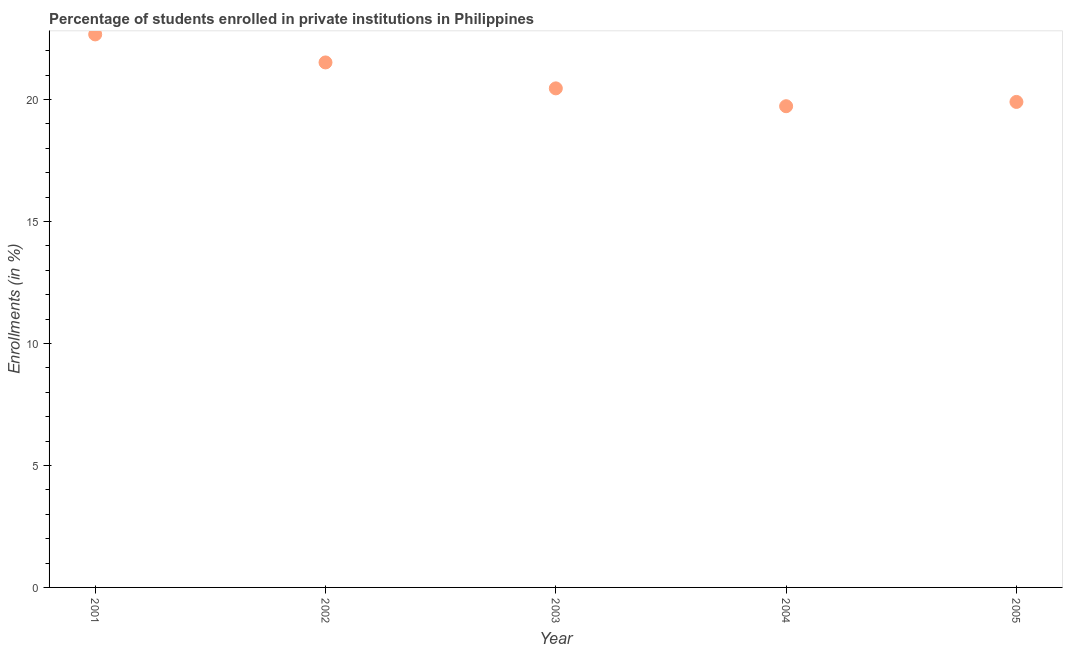What is the enrollments in private institutions in 2002?
Provide a short and direct response. 21.52. Across all years, what is the maximum enrollments in private institutions?
Your response must be concise. 22.67. Across all years, what is the minimum enrollments in private institutions?
Make the answer very short. 19.72. In which year was the enrollments in private institutions minimum?
Your answer should be very brief. 2004. What is the sum of the enrollments in private institutions?
Offer a very short reply. 104.26. What is the difference between the enrollments in private institutions in 2004 and 2005?
Give a very brief answer. -0.18. What is the average enrollments in private institutions per year?
Your answer should be very brief. 20.85. What is the median enrollments in private institutions?
Provide a succinct answer. 20.45. In how many years, is the enrollments in private institutions greater than 7 %?
Provide a short and direct response. 5. Do a majority of the years between 2003 and 2002 (inclusive) have enrollments in private institutions greater than 11 %?
Your response must be concise. No. What is the ratio of the enrollments in private institutions in 2002 to that in 2004?
Provide a short and direct response. 1.09. Is the difference between the enrollments in private institutions in 2002 and 2003 greater than the difference between any two years?
Keep it short and to the point. No. What is the difference between the highest and the second highest enrollments in private institutions?
Give a very brief answer. 1.15. What is the difference between the highest and the lowest enrollments in private institutions?
Your answer should be very brief. 2.94. In how many years, is the enrollments in private institutions greater than the average enrollments in private institutions taken over all years?
Give a very brief answer. 2. Does the enrollments in private institutions monotonically increase over the years?
Make the answer very short. No. How many dotlines are there?
Keep it short and to the point. 1. How many years are there in the graph?
Your answer should be very brief. 5. What is the difference between two consecutive major ticks on the Y-axis?
Your response must be concise. 5. Are the values on the major ticks of Y-axis written in scientific E-notation?
Offer a terse response. No. What is the title of the graph?
Give a very brief answer. Percentage of students enrolled in private institutions in Philippines. What is the label or title of the X-axis?
Offer a very short reply. Year. What is the label or title of the Y-axis?
Offer a terse response. Enrollments (in %). What is the Enrollments (in %) in 2001?
Make the answer very short. 22.67. What is the Enrollments (in %) in 2002?
Your answer should be very brief. 21.52. What is the Enrollments (in %) in 2003?
Your answer should be very brief. 20.45. What is the Enrollments (in %) in 2004?
Give a very brief answer. 19.72. What is the Enrollments (in %) in 2005?
Your answer should be compact. 19.9. What is the difference between the Enrollments (in %) in 2001 and 2002?
Provide a succinct answer. 1.15. What is the difference between the Enrollments (in %) in 2001 and 2003?
Your answer should be very brief. 2.21. What is the difference between the Enrollments (in %) in 2001 and 2004?
Offer a terse response. 2.94. What is the difference between the Enrollments (in %) in 2001 and 2005?
Offer a very short reply. 2.77. What is the difference between the Enrollments (in %) in 2002 and 2003?
Keep it short and to the point. 1.06. What is the difference between the Enrollments (in %) in 2002 and 2004?
Provide a short and direct response. 1.79. What is the difference between the Enrollments (in %) in 2002 and 2005?
Make the answer very short. 1.62. What is the difference between the Enrollments (in %) in 2003 and 2004?
Provide a short and direct response. 0.73. What is the difference between the Enrollments (in %) in 2003 and 2005?
Your answer should be very brief. 0.56. What is the difference between the Enrollments (in %) in 2004 and 2005?
Give a very brief answer. -0.18. What is the ratio of the Enrollments (in %) in 2001 to that in 2002?
Keep it short and to the point. 1.05. What is the ratio of the Enrollments (in %) in 2001 to that in 2003?
Offer a very short reply. 1.11. What is the ratio of the Enrollments (in %) in 2001 to that in 2004?
Your response must be concise. 1.15. What is the ratio of the Enrollments (in %) in 2001 to that in 2005?
Your response must be concise. 1.14. What is the ratio of the Enrollments (in %) in 2002 to that in 2003?
Offer a very short reply. 1.05. What is the ratio of the Enrollments (in %) in 2002 to that in 2004?
Give a very brief answer. 1.09. What is the ratio of the Enrollments (in %) in 2002 to that in 2005?
Your answer should be compact. 1.08. What is the ratio of the Enrollments (in %) in 2003 to that in 2005?
Make the answer very short. 1.03. What is the ratio of the Enrollments (in %) in 2004 to that in 2005?
Keep it short and to the point. 0.99. 